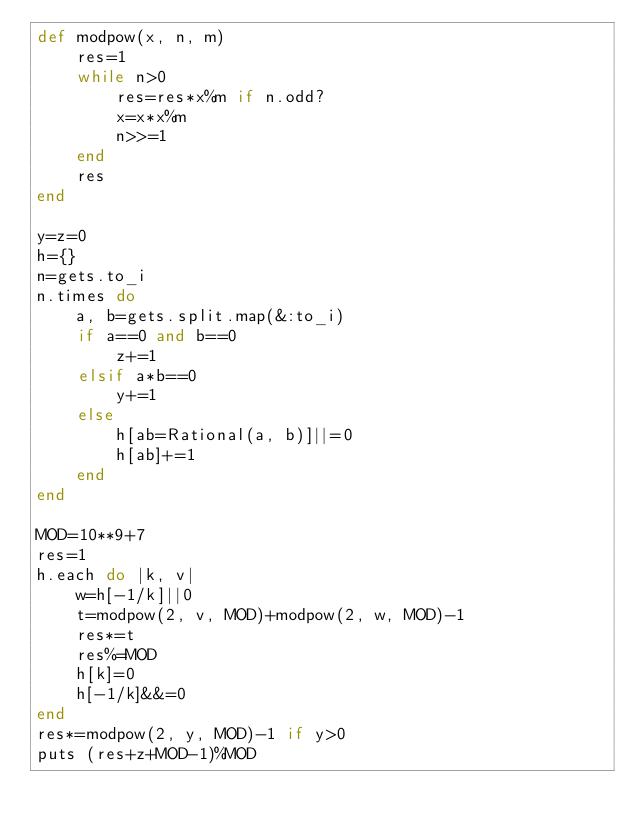Convert code to text. <code><loc_0><loc_0><loc_500><loc_500><_Ruby_>def modpow(x, n, m)
    res=1
    while n>0
        res=res*x%m if n.odd?
        x=x*x%m
        n>>=1
    end
    res
end

y=z=0
h={}
n=gets.to_i
n.times do
    a, b=gets.split.map(&:to_i)
    if a==0 and b==0
        z+=1
    elsif a*b==0
        y+=1
    else
        h[ab=Rational(a, b)]||=0
        h[ab]+=1
    end
end

MOD=10**9+7
res=1
h.each do |k, v|
    w=h[-1/k]||0
    t=modpow(2, v, MOD)+modpow(2, w, MOD)-1
    res*=t
    res%=MOD
    h[k]=0
    h[-1/k]&&=0
end
res*=modpow(2, y, MOD)-1 if y>0
puts (res+z+MOD-1)%MOD
</code> 